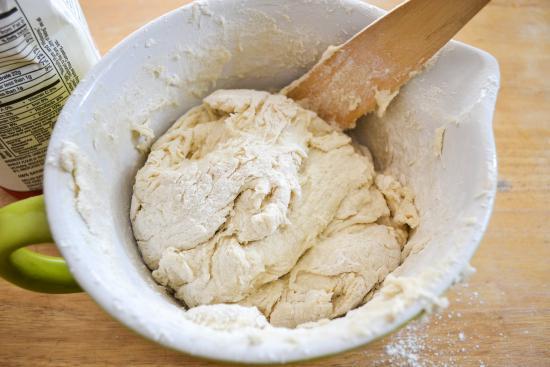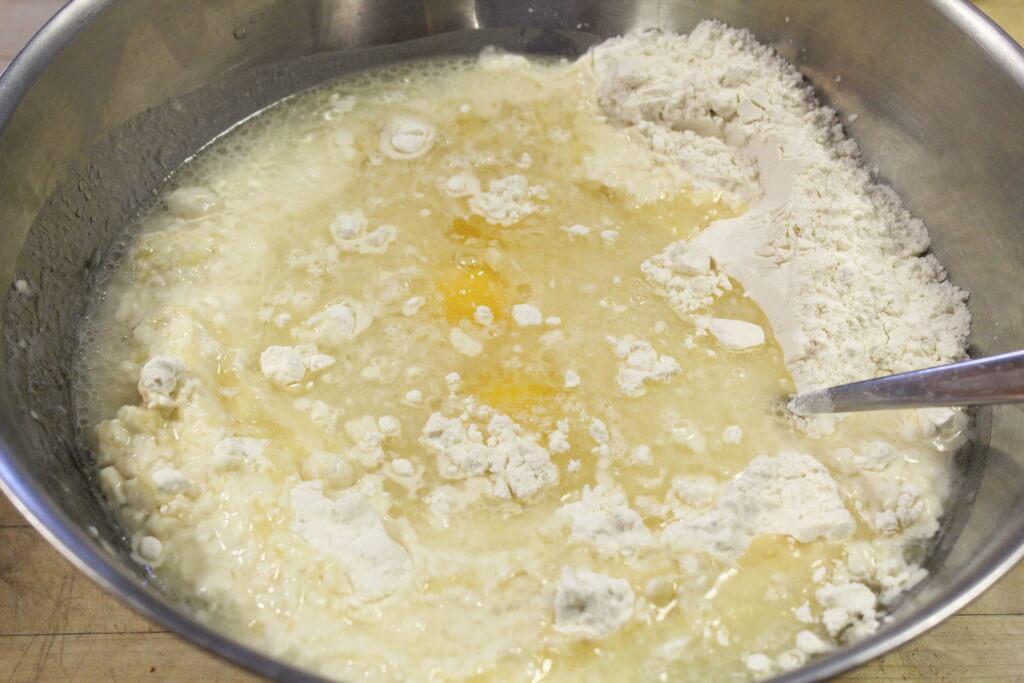The first image is the image on the left, the second image is the image on the right. Considering the images on both sides, is "A wooden rolling pin is seen in the image on the left." valid? Answer yes or no. No. The first image is the image on the left, the second image is the image on the right. For the images displayed, is the sentence "In one of the images there is a rolling pin." factually correct? Answer yes or no. No. 